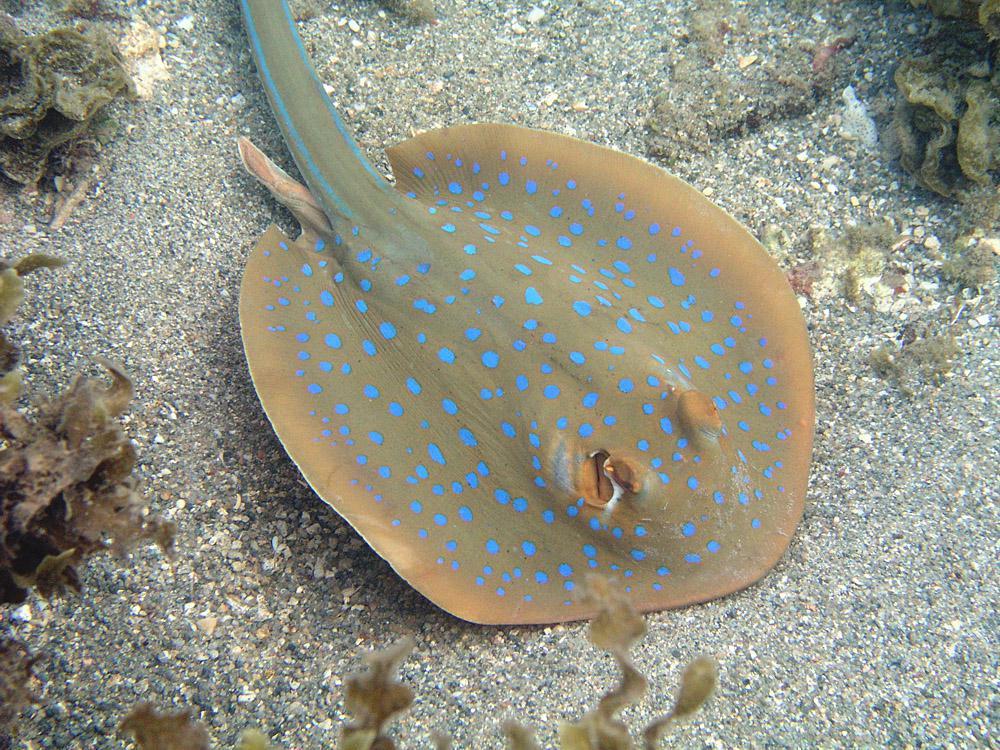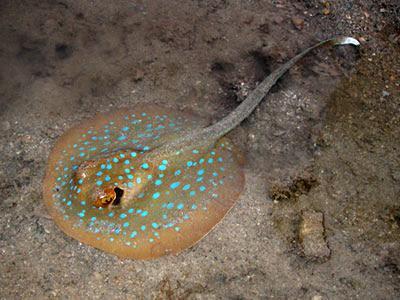The first image is the image on the left, the second image is the image on the right. Considering the images on both sides, is "The creature in the image on the right is pressed flat against the sea floor." valid? Answer yes or no. Yes. 